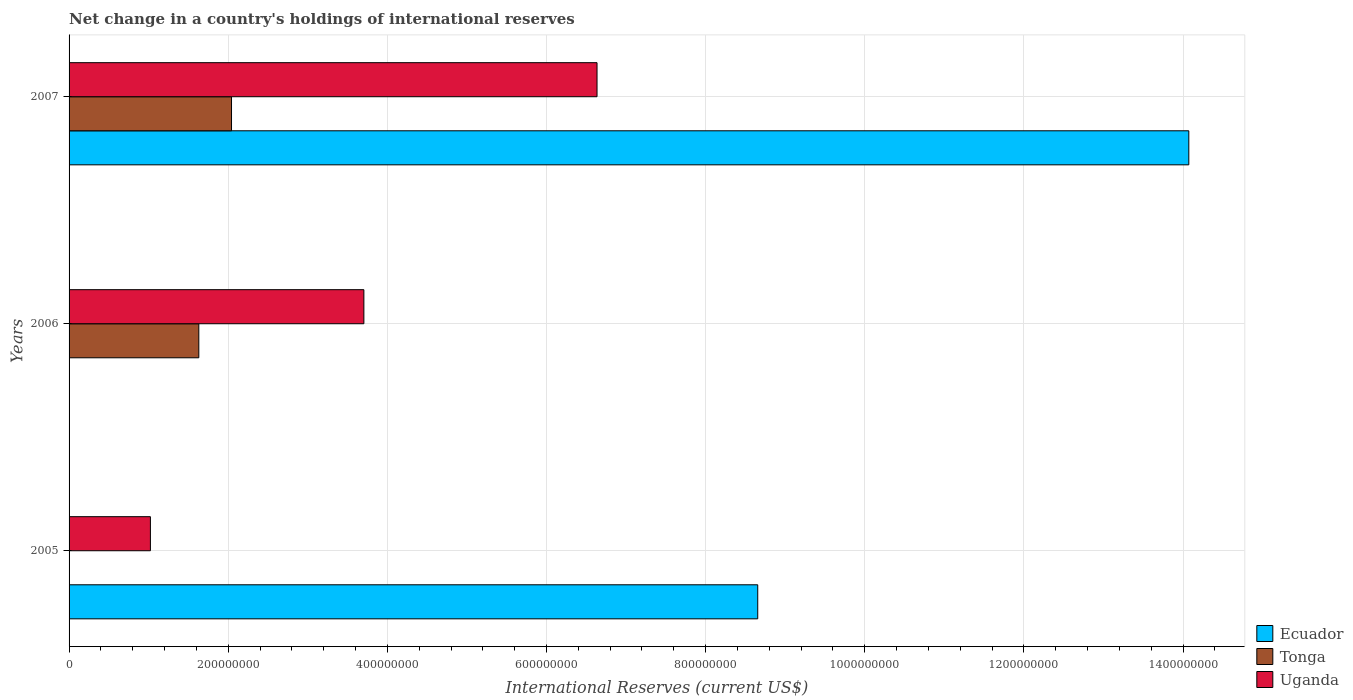How many different coloured bars are there?
Your answer should be compact. 3. How many groups of bars are there?
Provide a succinct answer. 3. Are the number of bars on each tick of the Y-axis equal?
Offer a very short reply. No. How many bars are there on the 3rd tick from the top?
Offer a terse response. 2. How many bars are there on the 1st tick from the bottom?
Offer a very short reply. 2. What is the label of the 2nd group of bars from the top?
Provide a succinct answer. 2006. What is the international reserves in Ecuador in 2005?
Make the answer very short. 8.65e+08. Across all years, what is the maximum international reserves in Tonga?
Give a very brief answer. 2.04e+08. Across all years, what is the minimum international reserves in Ecuador?
Provide a succinct answer. 0. In which year was the international reserves in Tonga maximum?
Your answer should be compact. 2007. What is the total international reserves in Tonga in the graph?
Your answer should be very brief. 3.67e+08. What is the difference between the international reserves in Ecuador in 2005 and that in 2007?
Your answer should be compact. -5.42e+08. What is the difference between the international reserves in Ecuador in 2006 and the international reserves in Uganda in 2005?
Give a very brief answer. -1.02e+08. What is the average international reserves in Tonga per year?
Provide a short and direct response. 1.22e+08. In the year 2006, what is the difference between the international reserves in Tonga and international reserves in Uganda?
Ensure brevity in your answer.  -2.07e+08. What is the ratio of the international reserves in Uganda in 2006 to that in 2007?
Keep it short and to the point. 0.56. Is the international reserves in Uganda in 2006 less than that in 2007?
Your answer should be very brief. Yes. What is the difference between the highest and the lowest international reserves in Uganda?
Make the answer very short. 5.61e+08. Is the sum of the international reserves in Uganda in 2006 and 2007 greater than the maximum international reserves in Tonga across all years?
Provide a short and direct response. Yes. Are all the bars in the graph horizontal?
Provide a succinct answer. Yes. How many years are there in the graph?
Provide a short and direct response. 3. Does the graph contain any zero values?
Keep it short and to the point. Yes. Does the graph contain grids?
Provide a succinct answer. Yes. How many legend labels are there?
Keep it short and to the point. 3. How are the legend labels stacked?
Give a very brief answer. Vertical. What is the title of the graph?
Ensure brevity in your answer.  Net change in a country's holdings of international reserves. What is the label or title of the X-axis?
Give a very brief answer. International Reserves (current US$). What is the label or title of the Y-axis?
Your answer should be compact. Years. What is the International Reserves (current US$) of Ecuador in 2005?
Provide a short and direct response. 8.65e+08. What is the International Reserves (current US$) of Tonga in 2005?
Ensure brevity in your answer.  0. What is the International Reserves (current US$) of Uganda in 2005?
Your response must be concise. 1.02e+08. What is the International Reserves (current US$) in Tonga in 2006?
Offer a terse response. 1.63e+08. What is the International Reserves (current US$) in Uganda in 2006?
Your answer should be compact. 3.70e+08. What is the International Reserves (current US$) in Ecuador in 2007?
Give a very brief answer. 1.41e+09. What is the International Reserves (current US$) in Tonga in 2007?
Your response must be concise. 2.04e+08. What is the International Reserves (current US$) of Uganda in 2007?
Offer a terse response. 6.64e+08. Across all years, what is the maximum International Reserves (current US$) of Ecuador?
Provide a short and direct response. 1.41e+09. Across all years, what is the maximum International Reserves (current US$) in Tonga?
Your answer should be compact. 2.04e+08. Across all years, what is the maximum International Reserves (current US$) of Uganda?
Provide a succinct answer. 6.64e+08. Across all years, what is the minimum International Reserves (current US$) of Ecuador?
Offer a terse response. 0. Across all years, what is the minimum International Reserves (current US$) in Uganda?
Provide a succinct answer. 1.02e+08. What is the total International Reserves (current US$) in Ecuador in the graph?
Your answer should be very brief. 2.27e+09. What is the total International Reserves (current US$) of Tonga in the graph?
Keep it short and to the point. 3.67e+08. What is the total International Reserves (current US$) of Uganda in the graph?
Give a very brief answer. 1.14e+09. What is the difference between the International Reserves (current US$) in Uganda in 2005 and that in 2006?
Your answer should be compact. -2.68e+08. What is the difference between the International Reserves (current US$) in Ecuador in 2005 and that in 2007?
Provide a short and direct response. -5.42e+08. What is the difference between the International Reserves (current US$) of Uganda in 2005 and that in 2007?
Provide a succinct answer. -5.61e+08. What is the difference between the International Reserves (current US$) of Tonga in 2006 and that in 2007?
Provide a short and direct response. -4.11e+07. What is the difference between the International Reserves (current US$) of Uganda in 2006 and that in 2007?
Make the answer very short. -2.93e+08. What is the difference between the International Reserves (current US$) of Ecuador in 2005 and the International Reserves (current US$) of Tonga in 2006?
Provide a succinct answer. 7.02e+08. What is the difference between the International Reserves (current US$) in Ecuador in 2005 and the International Reserves (current US$) in Uganda in 2006?
Offer a terse response. 4.95e+08. What is the difference between the International Reserves (current US$) in Ecuador in 2005 and the International Reserves (current US$) in Tonga in 2007?
Make the answer very short. 6.61e+08. What is the difference between the International Reserves (current US$) of Ecuador in 2005 and the International Reserves (current US$) of Uganda in 2007?
Your answer should be very brief. 2.02e+08. What is the difference between the International Reserves (current US$) in Tonga in 2006 and the International Reserves (current US$) in Uganda in 2007?
Your answer should be very brief. -5.00e+08. What is the average International Reserves (current US$) in Ecuador per year?
Provide a short and direct response. 7.58e+08. What is the average International Reserves (current US$) of Tonga per year?
Ensure brevity in your answer.  1.22e+08. What is the average International Reserves (current US$) of Uganda per year?
Your response must be concise. 3.79e+08. In the year 2005, what is the difference between the International Reserves (current US$) of Ecuador and International Reserves (current US$) of Uganda?
Make the answer very short. 7.63e+08. In the year 2006, what is the difference between the International Reserves (current US$) of Tonga and International Reserves (current US$) of Uganda?
Your answer should be compact. -2.07e+08. In the year 2007, what is the difference between the International Reserves (current US$) in Ecuador and International Reserves (current US$) in Tonga?
Provide a succinct answer. 1.20e+09. In the year 2007, what is the difference between the International Reserves (current US$) of Ecuador and International Reserves (current US$) of Uganda?
Provide a succinct answer. 7.44e+08. In the year 2007, what is the difference between the International Reserves (current US$) in Tonga and International Reserves (current US$) in Uganda?
Your answer should be very brief. -4.59e+08. What is the ratio of the International Reserves (current US$) in Uganda in 2005 to that in 2006?
Your answer should be very brief. 0.28. What is the ratio of the International Reserves (current US$) in Ecuador in 2005 to that in 2007?
Keep it short and to the point. 0.61. What is the ratio of the International Reserves (current US$) of Uganda in 2005 to that in 2007?
Provide a succinct answer. 0.15. What is the ratio of the International Reserves (current US$) of Tonga in 2006 to that in 2007?
Give a very brief answer. 0.8. What is the ratio of the International Reserves (current US$) in Uganda in 2006 to that in 2007?
Offer a very short reply. 0.56. What is the difference between the highest and the second highest International Reserves (current US$) in Uganda?
Offer a terse response. 2.93e+08. What is the difference between the highest and the lowest International Reserves (current US$) in Ecuador?
Your answer should be compact. 1.41e+09. What is the difference between the highest and the lowest International Reserves (current US$) of Tonga?
Your response must be concise. 2.04e+08. What is the difference between the highest and the lowest International Reserves (current US$) of Uganda?
Your answer should be compact. 5.61e+08. 